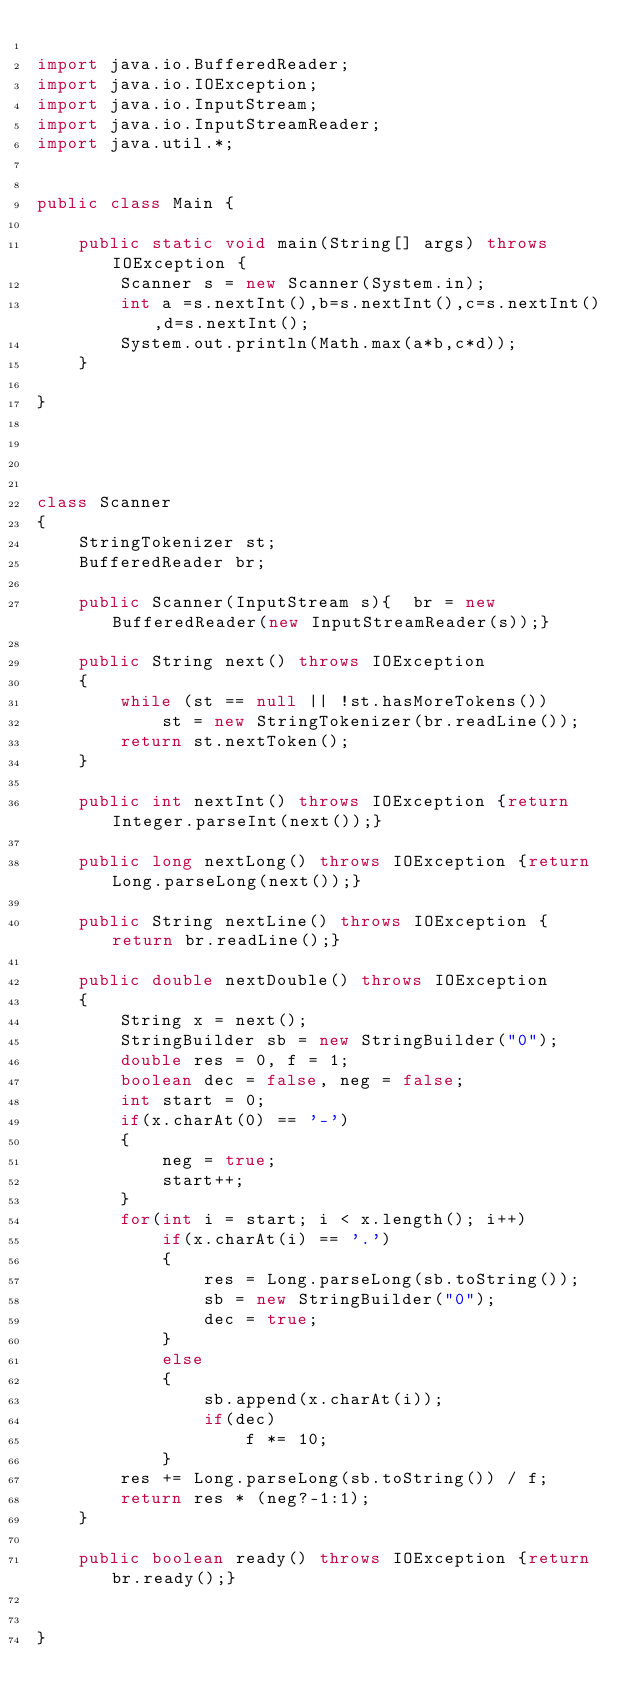<code> <loc_0><loc_0><loc_500><loc_500><_Java_>
import java.io.BufferedReader;
import java.io.IOException;
import java.io.InputStream;
import java.io.InputStreamReader;
import java.util.*;


public class Main {

    public static void main(String[] args) throws IOException {
        Scanner s = new Scanner(System.in);
        int a =s.nextInt(),b=s.nextInt(),c=s.nextInt(),d=s.nextInt();
        System.out.println(Math.max(a*b,c*d));
    }

}




class Scanner
{
    StringTokenizer st;
    BufferedReader br;

    public Scanner(InputStream s){	br = new BufferedReader(new InputStreamReader(s));}

    public String next() throws IOException
    {
        while (st == null || !st.hasMoreTokens())
            st = new StringTokenizer(br.readLine());
        return st.nextToken();
    }

    public int nextInt() throws IOException {return Integer.parseInt(next());}

    public long nextLong() throws IOException {return Long.parseLong(next());}

    public String nextLine() throws IOException {return br.readLine();}

    public double nextDouble() throws IOException
    {
        String x = next();
        StringBuilder sb = new StringBuilder("0");
        double res = 0, f = 1;
        boolean dec = false, neg = false;
        int start = 0;
        if(x.charAt(0) == '-')
        {
            neg = true;
            start++;
        }
        for(int i = start; i < x.length(); i++)
            if(x.charAt(i) == '.')
            {
                res = Long.parseLong(sb.toString());
                sb = new StringBuilder("0");
                dec = true;
            }
            else
            {
                sb.append(x.charAt(i));
                if(dec)
                    f *= 10;
            }
        res += Long.parseLong(sb.toString()) / f;
        return res * (neg?-1:1);
    }

    public boolean ready() throws IOException {return br.ready();}


}</code> 